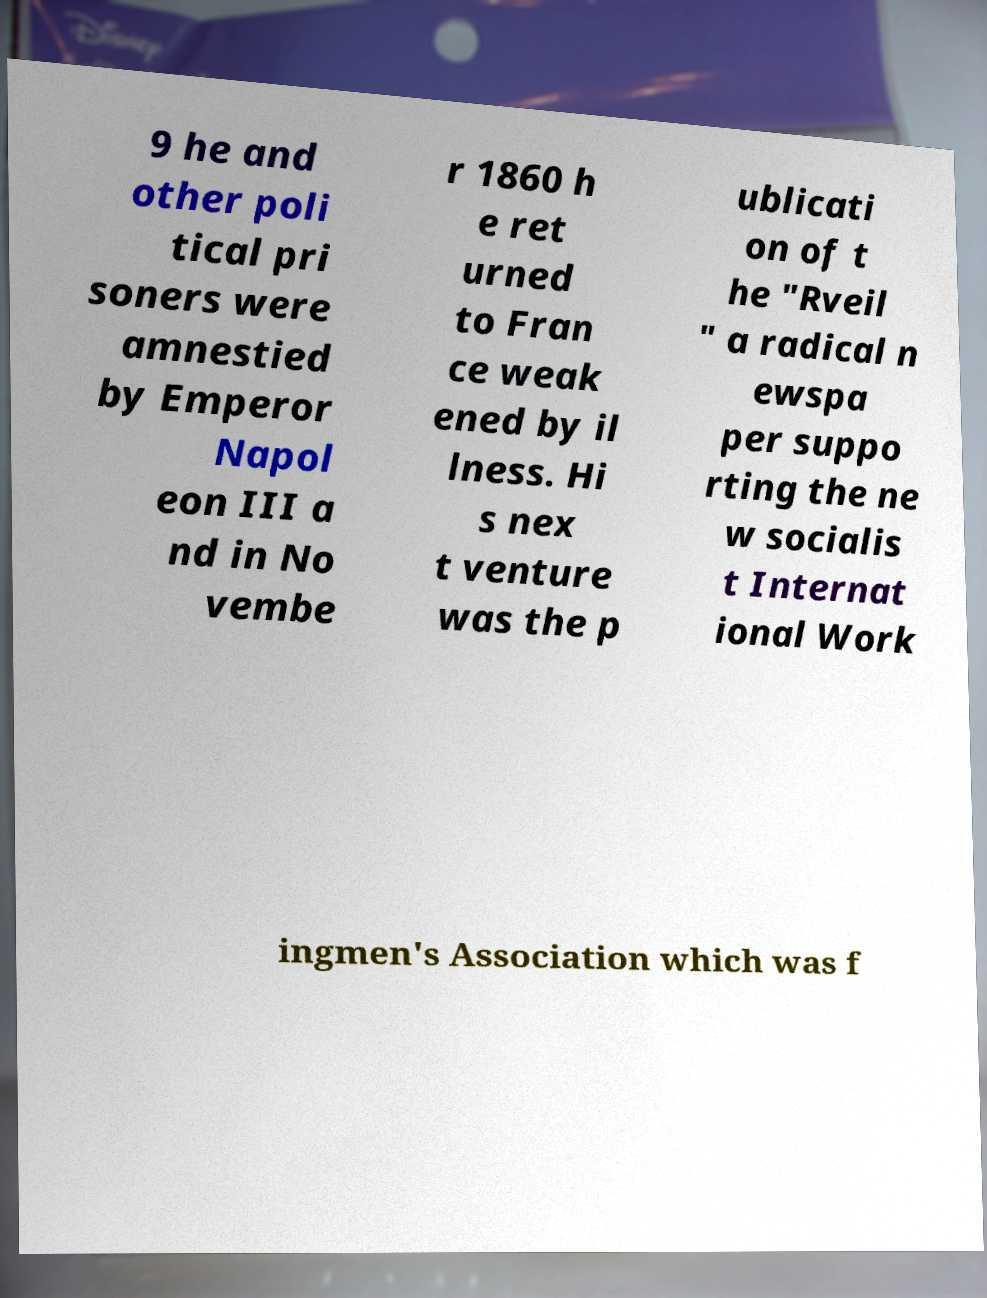Please read and relay the text visible in this image. What does it say? 9 he and other poli tical pri soners were amnestied by Emperor Napol eon III a nd in No vembe r 1860 h e ret urned to Fran ce weak ened by il lness. Hi s nex t venture was the p ublicati on of t he "Rveil " a radical n ewspa per suppo rting the ne w socialis t Internat ional Work ingmen's Association which was f 